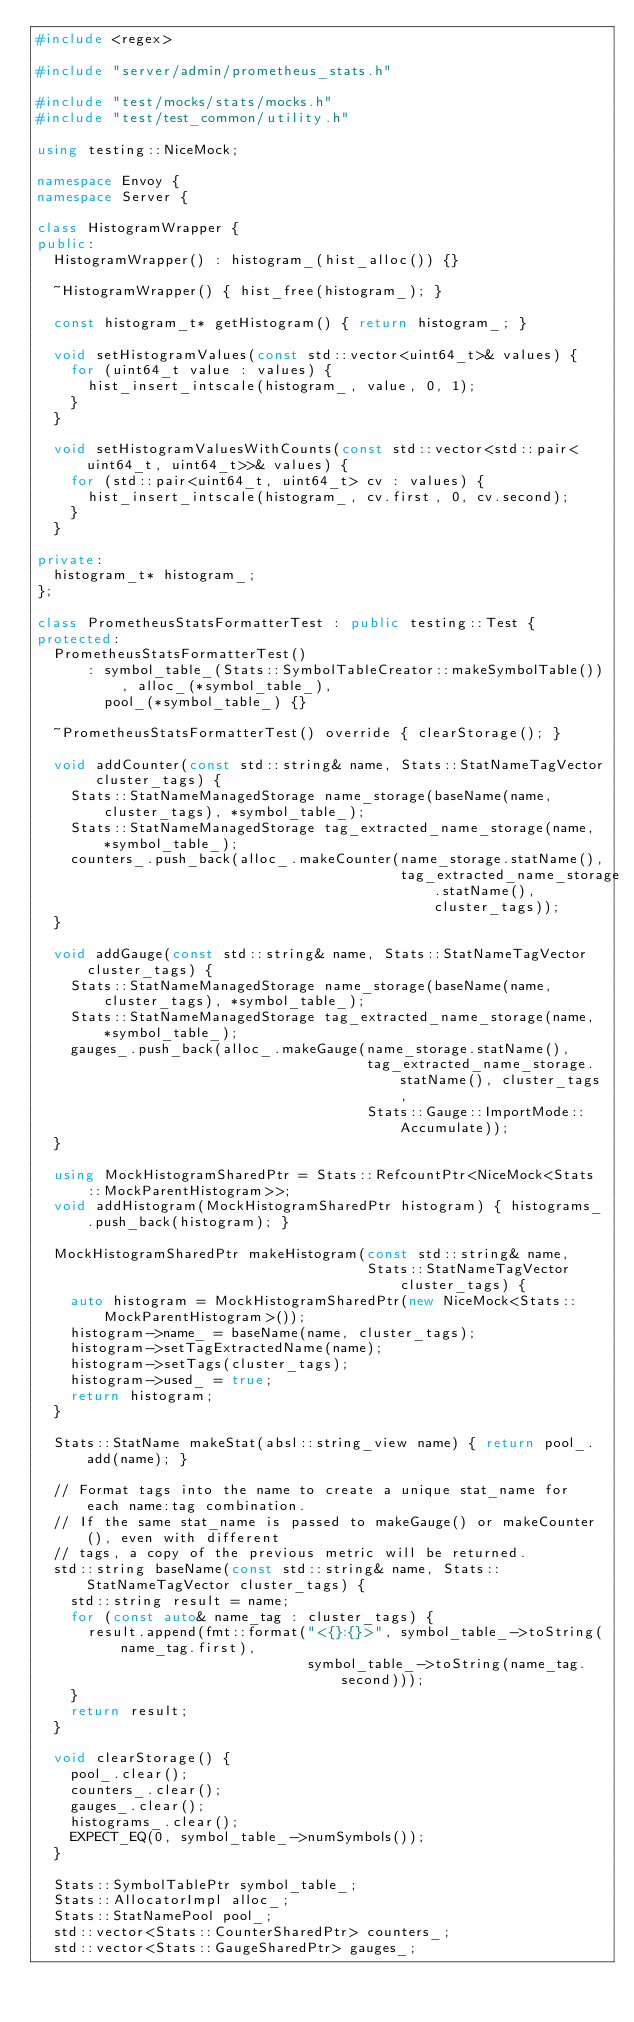Convert code to text. <code><loc_0><loc_0><loc_500><loc_500><_C++_>#include <regex>

#include "server/admin/prometheus_stats.h"

#include "test/mocks/stats/mocks.h"
#include "test/test_common/utility.h"

using testing::NiceMock;

namespace Envoy {
namespace Server {

class HistogramWrapper {
public:
  HistogramWrapper() : histogram_(hist_alloc()) {}

  ~HistogramWrapper() { hist_free(histogram_); }

  const histogram_t* getHistogram() { return histogram_; }

  void setHistogramValues(const std::vector<uint64_t>& values) {
    for (uint64_t value : values) {
      hist_insert_intscale(histogram_, value, 0, 1);
    }
  }

  void setHistogramValuesWithCounts(const std::vector<std::pair<uint64_t, uint64_t>>& values) {
    for (std::pair<uint64_t, uint64_t> cv : values) {
      hist_insert_intscale(histogram_, cv.first, 0, cv.second);
    }
  }

private:
  histogram_t* histogram_;
};

class PrometheusStatsFormatterTest : public testing::Test {
protected:
  PrometheusStatsFormatterTest()
      : symbol_table_(Stats::SymbolTableCreator::makeSymbolTable()), alloc_(*symbol_table_),
        pool_(*symbol_table_) {}

  ~PrometheusStatsFormatterTest() override { clearStorage(); }

  void addCounter(const std::string& name, Stats::StatNameTagVector cluster_tags) {
    Stats::StatNameManagedStorage name_storage(baseName(name, cluster_tags), *symbol_table_);
    Stats::StatNameManagedStorage tag_extracted_name_storage(name, *symbol_table_);
    counters_.push_back(alloc_.makeCounter(name_storage.statName(),
                                           tag_extracted_name_storage.statName(), cluster_tags));
  }

  void addGauge(const std::string& name, Stats::StatNameTagVector cluster_tags) {
    Stats::StatNameManagedStorage name_storage(baseName(name, cluster_tags), *symbol_table_);
    Stats::StatNameManagedStorage tag_extracted_name_storage(name, *symbol_table_);
    gauges_.push_back(alloc_.makeGauge(name_storage.statName(),
                                       tag_extracted_name_storage.statName(), cluster_tags,
                                       Stats::Gauge::ImportMode::Accumulate));
  }

  using MockHistogramSharedPtr = Stats::RefcountPtr<NiceMock<Stats::MockParentHistogram>>;
  void addHistogram(MockHistogramSharedPtr histogram) { histograms_.push_back(histogram); }

  MockHistogramSharedPtr makeHistogram(const std::string& name,
                                       Stats::StatNameTagVector cluster_tags) {
    auto histogram = MockHistogramSharedPtr(new NiceMock<Stats::MockParentHistogram>());
    histogram->name_ = baseName(name, cluster_tags);
    histogram->setTagExtractedName(name);
    histogram->setTags(cluster_tags);
    histogram->used_ = true;
    return histogram;
  }

  Stats::StatName makeStat(absl::string_view name) { return pool_.add(name); }

  // Format tags into the name to create a unique stat_name for each name:tag combination.
  // If the same stat_name is passed to makeGauge() or makeCounter(), even with different
  // tags, a copy of the previous metric will be returned.
  std::string baseName(const std::string& name, Stats::StatNameTagVector cluster_tags) {
    std::string result = name;
    for (const auto& name_tag : cluster_tags) {
      result.append(fmt::format("<{}:{}>", symbol_table_->toString(name_tag.first),
                                symbol_table_->toString(name_tag.second)));
    }
    return result;
  }

  void clearStorage() {
    pool_.clear();
    counters_.clear();
    gauges_.clear();
    histograms_.clear();
    EXPECT_EQ(0, symbol_table_->numSymbols());
  }

  Stats::SymbolTablePtr symbol_table_;
  Stats::AllocatorImpl alloc_;
  Stats::StatNamePool pool_;
  std::vector<Stats::CounterSharedPtr> counters_;
  std::vector<Stats::GaugeSharedPtr> gauges_;</code> 